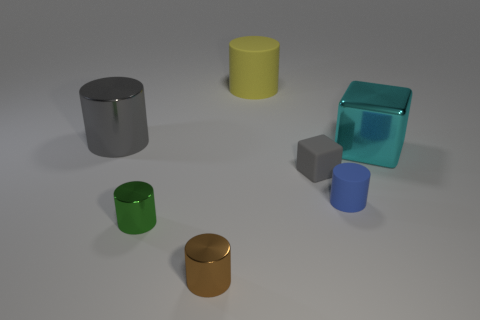Subtract 2 cylinders. How many cylinders are left? 3 Subtract all yellow rubber cylinders. How many cylinders are left? 4 Subtract all green cylinders. How many cylinders are left? 4 Subtract all cyan cylinders. Subtract all blue cubes. How many cylinders are left? 5 Add 2 blue rubber cylinders. How many objects exist? 9 Subtract all cubes. How many objects are left? 5 Add 1 metal blocks. How many metal blocks are left? 2 Add 2 tiny green rubber cylinders. How many tiny green rubber cylinders exist? 2 Subtract 0 purple blocks. How many objects are left? 7 Subtract all purple shiny objects. Subtract all yellow objects. How many objects are left? 6 